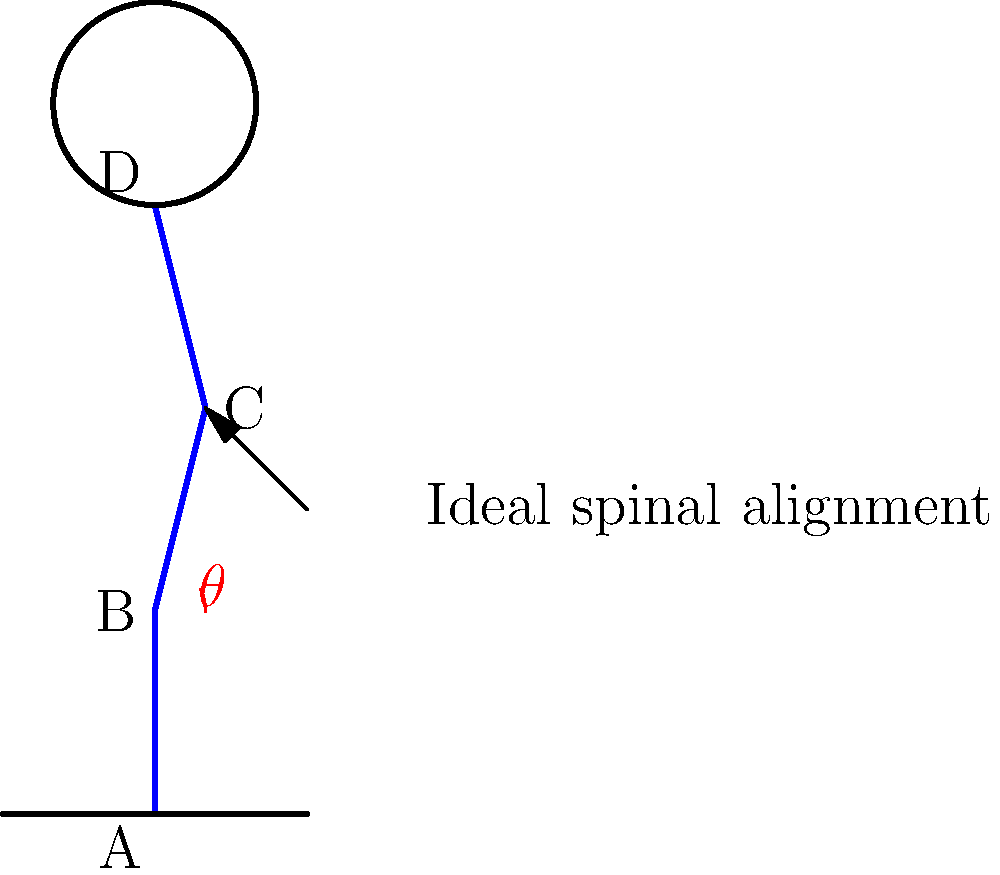During seated meditation, what is the ideal angle $\theta$ between the lower spine (AB) and the upper spine (CD) to maintain proper spinal alignment and reduce strain? To determine the ideal angle for proper spinal alignment during seated meditation, we need to consider the following steps:

1. Natural spinal curvature: The human spine has natural curves (cervical, thoracic, and lumbar) that should be maintained during meditation.

2. Neutral position: The goal is to keep the spine in a neutral position, which mimics its natural alignment when standing with good posture.

3. Lower back (lumbar) curve: The lower back should maintain a slight inward curve to support the upper body's weight.

4. Upper back (thoracic) and neck (cervical) alignment: These should be relatively straight, with the head balanced on top of the spine.

5. Ideal angle: Research in biomechanics and ergonomics suggests that the ideal angle $\theta$ between the lower spine (AB) and the upper spine (CD) is approximately 25-30 degrees.

6. Benefits of this angle:
   a) Reduces strain on the lower back muscles
   b) Maintains the natural lumbar curve
   c) Allows for proper weight distribution
   d) Facilitates easier breathing
   e) Promotes alertness and comfort during long meditation sessions

7. Adjustments: This angle can be achieved by sitting on a cushion or meditation bench that slightly elevates the hips, naturally tilting the pelvis forward and creating the desired spinal alignment.
Answer: 25-30 degrees 